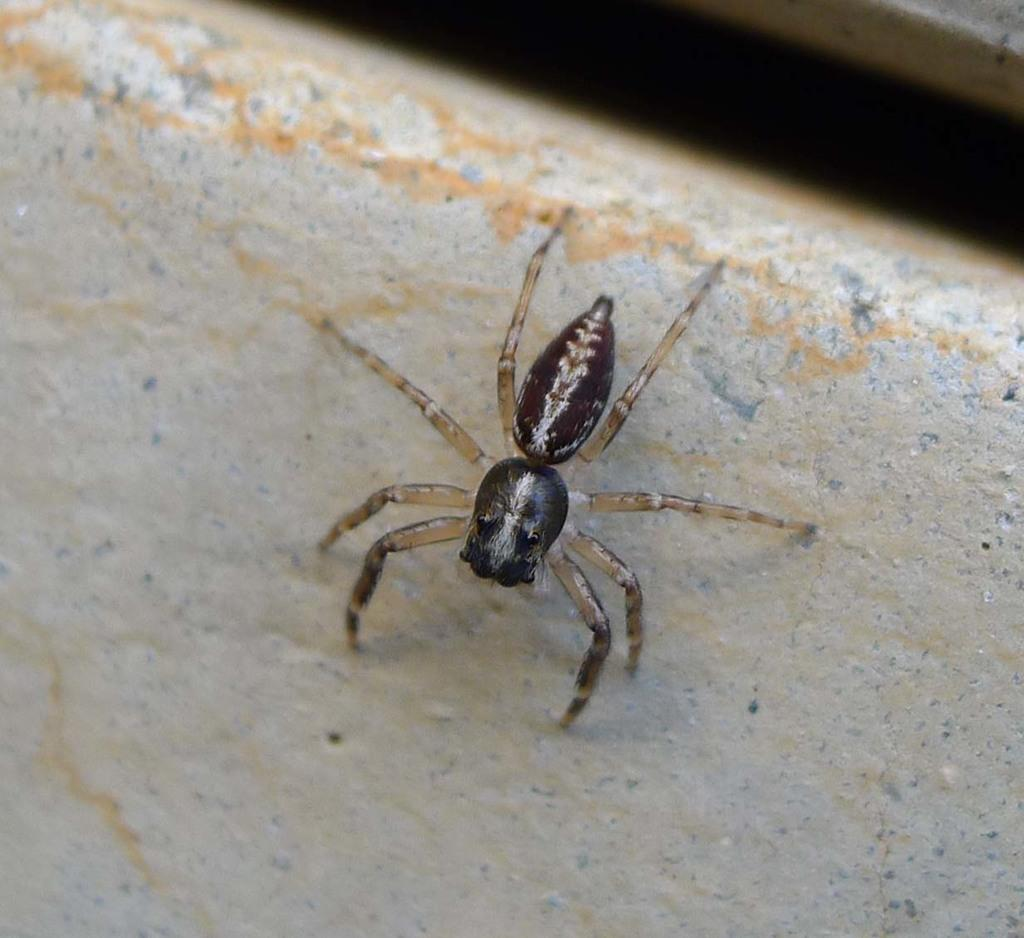What color is the spider in the image? The spider in the image is black-colored. What type of cork is the spider using to make a decision in the image? There is no cork or decision-making process depicted in the image; it simply features a black-colored spider. 